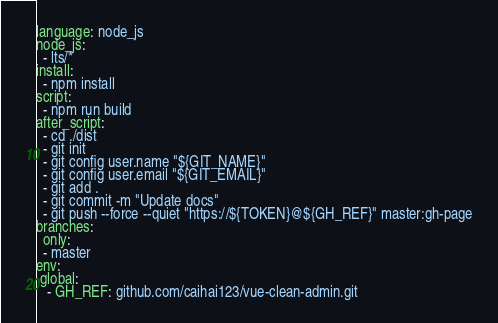<code> <loc_0><loc_0><loc_500><loc_500><_YAML_>language: node_js
node_js:
  - lts/*
install:
  - npm install
script:
  - npm run build 
after_script:
  - cd ./dist
  - git init
  - git config user.name "${GIT_NAME}"
  - git config user.email "${GIT_EMAIL}"
  - git add .
  - git commit -m "Update docs"
  - git push --force --quiet "https://${TOKEN}@${GH_REF}" master:gh-page
branches:
  only:
  - master
env:
 global:
   - GH_REF: github.com/caihai123/vue-clean-admin.git
</code> 